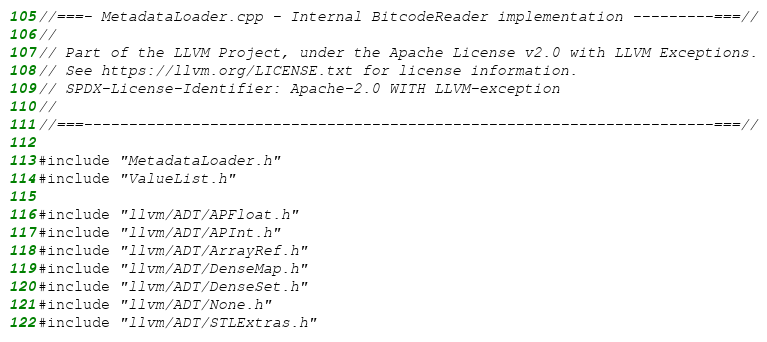<code> <loc_0><loc_0><loc_500><loc_500><_C++_>//===- MetadataLoader.cpp - Internal BitcodeReader implementation ---------===//
//
// Part of the LLVM Project, under the Apache License v2.0 with LLVM Exceptions.
// See https://llvm.org/LICENSE.txt for license information.
// SPDX-License-Identifier: Apache-2.0 WITH LLVM-exception
//
//===----------------------------------------------------------------------===//

#include "MetadataLoader.h"
#include "ValueList.h"

#include "llvm/ADT/APFloat.h"
#include "llvm/ADT/APInt.h"
#include "llvm/ADT/ArrayRef.h"
#include "llvm/ADT/DenseMap.h"
#include "llvm/ADT/DenseSet.h"
#include "llvm/ADT/None.h"
#include "llvm/ADT/STLExtras.h"</code> 